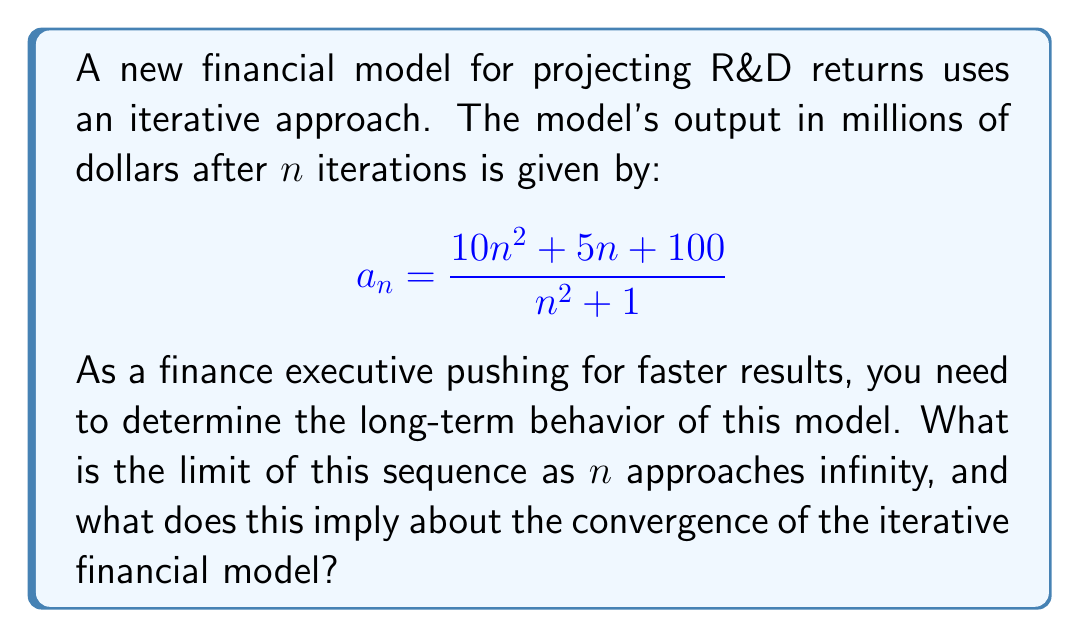Can you solve this math problem? To determine the limit of the sequence as n approaches infinity, we'll follow these steps:

1) First, let's examine the general term of the sequence:

   $$a_n = \frac{10n^2 + 5n + 100}{n^2 + 1}$$

2) To find the limit as n approaches infinity, we can divide both the numerator and denominator by the highest power of n in the denominator, which is n^2:

   $$\lim_{n \to \infty} a_n = \lim_{n \to \infty} \frac{\frac{10n^2}{n^2} + \frac{5n}{n^2} + \frac{100}{n^2}}{\frac{n^2}{n^2} + \frac{1}{n^2}}$$

3) Simplify:

   $$\lim_{n \to \infty} a_n = \lim_{n \to \infty} \frac{10 + \frac{5}{n} + \frac{100}{n^2}}{1 + \frac{1}{n^2}}$$

4) As n approaches infinity, the terms $\frac{5}{n}$, $\frac{100}{n^2}$, and $\frac{1}{n^2}$ all approach 0:

   $$\lim_{n \to \infty} a_n = \frac{10 + 0 + 0}{1 + 0} = 10$$

5) Therefore, the sequence converges to 10 as n approaches infinity.

This implies that the iterative financial model converges to a stable value of $10 million in the long run, regardless of the number of iterations performed beyond a certain point. For a finance executive pushing for faster results, this means that running the model for a very large number of iterations may not significantly change the output, and a reasonable approximation can be achieved with fewer iterations.
Answer: $10 million 